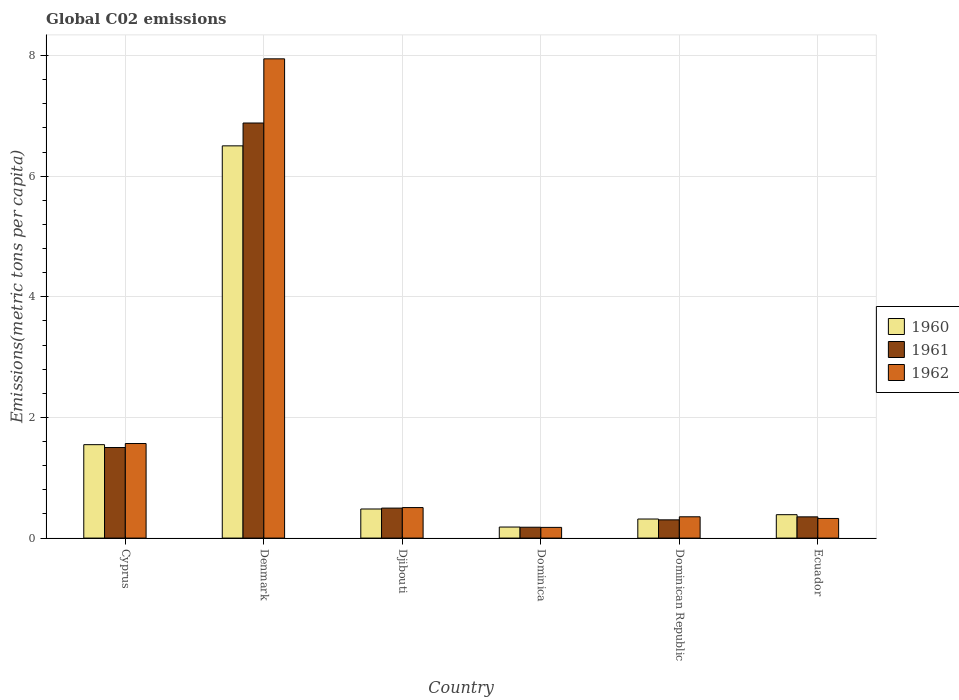How many different coloured bars are there?
Provide a succinct answer. 3. Are the number of bars on each tick of the X-axis equal?
Ensure brevity in your answer.  Yes. How many bars are there on the 5th tick from the right?
Your answer should be compact. 3. What is the label of the 4th group of bars from the left?
Offer a terse response. Dominica. In how many cases, is the number of bars for a given country not equal to the number of legend labels?
Your answer should be compact. 0. What is the amount of CO2 emitted in in 1960 in Denmark?
Your answer should be very brief. 6.5. Across all countries, what is the maximum amount of CO2 emitted in in 1961?
Ensure brevity in your answer.  6.88. Across all countries, what is the minimum amount of CO2 emitted in in 1960?
Ensure brevity in your answer.  0.18. In which country was the amount of CO2 emitted in in 1961 minimum?
Provide a short and direct response. Dominica. What is the total amount of CO2 emitted in in 1961 in the graph?
Offer a very short reply. 9.71. What is the difference between the amount of CO2 emitted in in 1960 in Dominica and that in Ecuador?
Your answer should be compact. -0.2. What is the difference between the amount of CO2 emitted in in 1960 in Djibouti and the amount of CO2 emitted in in 1961 in Denmark?
Your answer should be compact. -6.4. What is the average amount of CO2 emitted in in 1962 per country?
Offer a terse response. 1.81. What is the difference between the amount of CO2 emitted in of/in 1961 and amount of CO2 emitted in of/in 1962 in Djibouti?
Give a very brief answer. -0.01. What is the ratio of the amount of CO2 emitted in in 1961 in Dominica to that in Dominican Republic?
Offer a terse response. 0.6. Is the difference between the amount of CO2 emitted in in 1961 in Cyprus and Dominica greater than the difference between the amount of CO2 emitted in in 1962 in Cyprus and Dominica?
Ensure brevity in your answer.  No. What is the difference between the highest and the second highest amount of CO2 emitted in in 1961?
Provide a succinct answer. -1. What is the difference between the highest and the lowest amount of CO2 emitted in in 1960?
Ensure brevity in your answer.  6.32. In how many countries, is the amount of CO2 emitted in in 1962 greater than the average amount of CO2 emitted in in 1962 taken over all countries?
Offer a very short reply. 1. What does the 2nd bar from the left in Dominican Republic represents?
Offer a very short reply. 1961. What does the 2nd bar from the right in Dominica represents?
Provide a succinct answer. 1961. Is it the case that in every country, the sum of the amount of CO2 emitted in in 1961 and amount of CO2 emitted in in 1962 is greater than the amount of CO2 emitted in in 1960?
Keep it short and to the point. Yes. How many countries are there in the graph?
Ensure brevity in your answer.  6. What is the difference between two consecutive major ticks on the Y-axis?
Your response must be concise. 2. Does the graph contain any zero values?
Give a very brief answer. No. Does the graph contain grids?
Keep it short and to the point. Yes. How are the legend labels stacked?
Make the answer very short. Vertical. What is the title of the graph?
Make the answer very short. Global C02 emissions. What is the label or title of the Y-axis?
Keep it short and to the point. Emissions(metric tons per capita). What is the Emissions(metric tons per capita) of 1960 in Cyprus?
Provide a short and direct response. 1.55. What is the Emissions(metric tons per capita) in 1961 in Cyprus?
Offer a very short reply. 1.5. What is the Emissions(metric tons per capita) of 1962 in Cyprus?
Your answer should be very brief. 1.57. What is the Emissions(metric tons per capita) in 1960 in Denmark?
Your answer should be very brief. 6.5. What is the Emissions(metric tons per capita) of 1961 in Denmark?
Your answer should be very brief. 6.88. What is the Emissions(metric tons per capita) in 1962 in Denmark?
Offer a very short reply. 7.95. What is the Emissions(metric tons per capita) in 1960 in Djibouti?
Offer a very short reply. 0.48. What is the Emissions(metric tons per capita) in 1961 in Djibouti?
Provide a short and direct response. 0.5. What is the Emissions(metric tons per capita) of 1962 in Djibouti?
Give a very brief answer. 0.51. What is the Emissions(metric tons per capita) in 1960 in Dominica?
Provide a succinct answer. 0.18. What is the Emissions(metric tons per capita) of 1961 in Dominica?
Offer a terse response. 0.18. What is the Emissions(metric tons per capita) in 1962 in Dominica?
Offer a very short reply. 0.18. What is the Emissions(metric tons per capita) of 1960 in Dominican Republic?
Your answer should be compact. 0.32. What is the Emissions(metric tons per capita) of 1961 in Dominican Republic?
Make the answer very short. 0.3. What is the Emissions(metric tons per capita) in 1962 in Dominican Republic?
Keep it short and to the point. 0.35. What is the Emissions(metric tons per capita) of 1960 in Ecuador?
Ensure brevity in your answer.  0.39. What is the Emissions(metric tons per capita) of 1961 in Ecuador?
Your answer should be compact. 0.35. What is the Emissions(metric tons per capita) of 1962 in Ecuador?
Your answer should be compact. 0.33. Across all countries, what is the maximum Emissions(metric tons per capita) in 1960?
Provide a succinct answer. 6.5. Across all countries, what is the maximum Emissions(metric tons per capita) of 1961?
Provide a succinct answer. 6.88. Across all countries, what is the maximum Emissions(metric tons per capita) in 1962?
Your response must be concise. 7.95. Across all countries, what is the minimum Emissions(metric tons per capita) of 1960?
Make the answer very short. 0.18. Across all countries, what is the minimum Emissions(metric tons per capita) in 1961?
Give a very brief answer. 0.18. Across all countries, what is the minimum Emissions(metric tons per capita) of 1962?
Offer a very short reply. 0.18. What is the total Emissions(metric tons per capita) in 1960 in the graph?
Your response must be concise. 9.42. What is the total Emissions(metric tons per capita) of 1961 in the graph?
Your response must be concise. 9.71. What is the total Emissions(metric tons per capita) of 1962 in the graph?
Your answer should be compact. 10.87. What is the difference between the Emissions(metric tons per capita) of 1960 in Cyprus and that in Denmark?
Keep it short and to the point. -4.95. What is the difference between the Emissions(metric tons per capita) of 1961 in Cyprus and that in Denmark?
Your response must be concise. -5.38. What is the difference between the Emissions(metric tons per capita) of 1962 in Cyprus and that in Denmark?
Provide a short and direct response. -6.38. What is the difference between the Emissions(metric tons per capita) in 1960 in Cyprus and that in Djibouti?
Your answer should be very brief. 1.07. What is the difference between the Emissions(metric tons per capita) in 1961 in Cyprus and that in Djibouti?
Your response must be concise. 1. What is the difference between the Emissions(metric tons per capita) of 1962 in Cyprus and that in Djibouti?
Make the answer very short. 1.06. What is the difference between the Emissions(metric tons per capita) in 1960 in Cyprus and that in Dominica?
Keep it short and to the point. 1.37. What is the difference between the Emissions(metric tons per capita) in 1961 in Cyprus and that in Dominica?
Provide a succinct answer. 1.32. What is the difference between the Emissions(metric tons per capita) in 1962 in Cyprus and that in Dominica?
Your answer should be compact. 1.39. What is the difference between the Emissions(metric tons per capita) in 1960 in Cyprus and that in Dominican Republic?
Your answer should be compact. 1.23. What is the difference between the Emissions(metric tons per capita) in 1961 in Cyprus and that in Dominican Republic?
Offer a terse response. 1.2. What is the difference between the Emissions(metric tons per capita) of 1962 in Cyprus and that in Dominican Republic?
Ensure brevity in your answer.  1.21. What is the difference between the Emissions(metric tons per capita) in 1960 in Cyprus and that in Ecuador?
Ensure brevity in your answer.  1.16. What is the difference between the Emissions(metric tons per capita) in 1961 in Cyprus and that in Ecuador?
Your answer should be compact. 1.15. What is the difference between the Emissions(metric tons per capita) of 1962 in Cyprus and that in Ecuador?
Your answer should be compact. 1.24. What is the difference between the Emissions(metric tons per capita) in 1960 in Denmark and that in Djibouti?
Give a very brief answer. 6.02. What is the difference between the Emissions(metric tons per capita) of 1961 in Denmark and that in Djibouti?
Your response must be concise. 6.38. What is the difference between the Emissions(metric tons per capita) in 1962 in Denmark and that in Djibouti?
Your response must be concise. 7.44. What is the difference between the Emissions(metric tons per capita) in 1960 in Denmark and that in Dominica?
Provide a succinct answer. 6.32. What is the difference between the Emissions(metric tons per capita) in 1961 in Denmark and that in Dominica?
Keep it short and to the point. 6.7. What is the difference between the Emissions(metric tons per capita) in 1962 in Denmark and that in Dominica?
Your answer should be compact. 7.77. What is the difference between the Emissions(metric tons per capita) in 1960 in Denmark and that in Dominican Republic?
Keep it short and to the point. 6.19. What is the difference between the Emissions(metric tons per capita) in 1961 in Denmark and that in Dominican Republic?
Your answer should be very brief. 6.58. What is the difference between the Emissions(metric tons per capita) of 1962 in Denmark and that in Dominican Republic?
Keep it short and to the point. 7.59. What is the difference between the Emissions(metric tons per capita) in 1960 in Denmark and that in Ecuador?
Your answer should be very brief. 6.11. What is the difference between the Emissions(metric tons per capita) in 1961 in Denmark and that in Ecuador?
Ensure brevity in your answer.  6.53. What is the difference between the Emissions(metric tons per capita) of 1962 in Denmark and that in Ecuador?
Your answer should be very brief. 7.62. What is the difference between the Emissions(metric tons per capita) of 1960 in Djibouti and that in Dominica?
Your answer should be very brief. 0.3. What is the difference between the Emissions(metric tons per capita) of 1961 in Djibouti and that in Dominica?
Provide a short and direct response. 0.32. What is the difference between the Emissions(metric tons per capita) in 1962 in Djibouti and that in Dominica?
Offer a terse response. 0.33. What is the difference between the Emissions(metric tons per capita) of 1960 in Djibouti and that in Dominican Republic?
Ensure brevity in your answer.  0.17. What is the difference between the Emissions(metric tons per capita) of 1961 in Djibouti and that in Dominican Republic?
Provide a succinct answer. 0.19. What is the difference between the Emissions(metric tons per capita) of 1962 in Djibouti and that in Dominican Republic?
Your answer should be very brief. 0.15. What is the difference between the Emissions(metric tons per capita) in 1960 in Djibouti and that in Ecuador?
Give a very brief answer. 0.09. What is the difference between the Emissions(metric tons per capita) of 1961 in Djibouti and that in Ecuador?
Provide a short and direct response. 0.15. What is the difference between the Emissions(metric tons per capita) of 1962 in Djibouti and that in Ecuador?
Make the answer very short. 0.18. What is the difference between the Emissions(metric tons per capita) in 1960 in Dominica and that in Dominican Republic?
Offer a very short reply. -0.13. What is the difference between the Emissions(metric tons per capita) in 1961 in Dominica and that in Dominican Republic?
Ensure brevity in your answer.  -0.12. What is the difference between the Emissions(metric tons per capita) in 1962 in Dominica and that in Dominican Republic?
Give a very brief answer. -0.18. What is the difference between the Emissions(metric tons per capita) in 1960 in Dominica and that in Ecuador?
Make the answer very short. -0.2. What is the difference between the Emissions(metric tons per capita) of 1961 in Dominica and that in Ecuador?
Keep it short and to the point. -0.17. What is the difference between the Emissions(metric tons per capita) of 1962 in Dominica and that in Ecuador?
Give a very brief answer. -0.15. What is the difference between the Emissions(metric tons per capita) of 1960 in Dominican Republic and that in Ecuador?
Keep it short and to the point. -0.07. What is the difference between the Emissions(metric tons per capita) of 1961 in Dominican Republic and that in Ecuador?
Your answer should be compact. -0.05. What is the difference between the Emissions(metric tons per capita) in 1962 in Dominican Republic and that in Ecuador?
Your answer should be compact. 0.03. What is the difference between the Emissions(metric tons per capita) in 1960 in Cyprus and the Emissions(metric tons per capita) in 1961 in Denmark?
Give a very brief answer. -5.33. What is the difference between the Emissions(metric tons per capita) of 1960 in Cyprus and the Emissions(metric tons per capita) of 1962 in Denmark?
Your response must be concise. -6.4. What is the difference between the Emissions(metric tons per capita) of 1961 in Cyprus and the Emissions(metric tons per capita) of 1962 in Denmark?
Provide a succinct answer. -6.44. What is the difference between the Emissions(metric tons per capita) of 1960 in Cyprus and the Emissions(metric tons per capita) of 1961 in Djibouti?
Offer a very short reply. 1.05. What is the difference between the Emissions(metric tons per capita) of 1960 in Cyprus and the Emissions(metric tons per capita) of 1962 in Djibouti?
Provide a short and direct response. 1.04. What is the difference between the Emissions(metric tons per capita) in 1960 in Cyprus and the Emissions(metric tons per capita) in 1961 in Dominica?
Ensure brevity in your answer.  1.37. What is the difference between the Emissions(metric tons per capita) of 1960 in Cyprus and the Emissions(metric tons per capita) of 1962 in Dominica?
Make the answer very short. 1.37. What is the difference between the Emissions(metric tons per capita) in 1961 in Cyprus and the Emissions(metric tons per capita) in 1962 in Dominica?
Ensure brevity in your answer.  1.32. What is the difference between the Emissions(metric tons per capita) in 1960 in Cyprus and the Emissions(metric tons per capita) in 1961 in Dominican Republic?
Keep it short and to the point. 1.25. What is the difference between the Emissions(metric tons per capita) in 1960 in Cyprus and the Emissions(metric tons per capita) in 1962 in Dominican Republic?
Give a very brief answer. 1.2. What is the difference between the Emissions(metric tons per capita) of 1961 in Cyprus and the Emissions(metric tons per capita) of 1962 in Dominican Republic?
Keep it short and to the point. 1.15. What is the difference between the Emissions(metric tons per capita) of 1960 in Cyprus and the Emissions(metric tons per capita) of 1961 in Ecuador?
Your answer should be very brief. 1.2. What is the difference between the Emissions(metric tons per capita) of 1960 in Cyprus and the Emissions(metric tons per capita) of 1962 in Ecuador?
Keep it short and to the point. 1.22. What is the difference between the Emissions(metric tons per capita) of 1961 in Cyprus and the Emissions(metric tons per capita) of 1962 in Ecuador?
Your response must be concise. 1.18. What is the difference between the Emissions(metric tons per capita) in 1960 in Denmark and the Emissions(metric tons per capita) in 1961 in Djibouti?
Your answer should be very brief. 6.01. What is the difference between the Emissions(metric tons per capita) in 1960 in Denmark and the Emissions(metric tons per capita) in 1962 in Djibouti?
Provide a succinct answer. 6. What is the difference between the Emissions(metric tons per capita) in 1961 in Denmark and the Emissions(metric tons per capita) in 1962 in Djibouti?
Offer a very short reply. 6.38. What is the difference between the Emissions(metric tons per capita) in 1960 in Denmark and the Emissions(metric tons per capita) in 1961 in Dominica?
Provide a succinct answer. 6.32. What is the difference between the Emissions(metric tons per capita) of 1960 in Denmark and the Emissions(metric tons per capita) of 1962 in Dominica?
Provide a short and direct response. 6.33. What is the difference between the Emissions(metric tons per capita) of 1961 in Denmark and the Emissions(metric tons per capita) of 1962 in Dominica?
Keep it short and to the point. 6.7. What is the difference between the Emissions(metric tons per capita) of 1960 in Denmark and the Emissions(metric tons per capita) of 1961 in Dominican Republic?
Your answer should be compact. 6.2. What is the difference between the Emissions(metric tons per capita) of 1960 in Denmark and the Emissions(metric tons per capita) of 1962 in Dominican Republic?
Give a very brief answer. 6.15. What is the difference between the Emissions(metric tons per capita) of 1961 in Denmark and the Emissions(metric tons per capita) of 1962 in Dominican Republic?
Your answer should be very brief. 6.53. What is the difference between the Emissions(metric tons per capita) in 1960 in Denmark and the Emissions(metric tons per capita) in 1961 in Ecuador?
Keep it short and to the point. 6.15. What is the difference between the Emissions(metric tons per capita) of 1960 in Denmark and the Emissions(metric tons per capita) of 1962 in Ecuador?
Offer a terse response. 6.18. What is the difference between the Emissions(metric tons per capita) of 1961 in Denmark and the Emissions(metric tons per capita) of 1962 in Ecuador?
Provide a short and direct response. 6.56. What is the difference between the Emissions(metric tons per capita) in 1960 in Djibouti and the Emissions(metric tons per capita) in 1961 in Dominica?
Give a very brief answer. 0.3. What is the difference between the Emissions(metric tons per capita) of 1960 in Djibouti and the Emissions(metric tons per capita) of 1962 in Dominica?
Give a very brief answer. 0.3. What is the difference between the Emissions(metric tons per capita) in 1961 in Djibouti and the Emissions(metric tons per capita) in 1962 in Dominica?
Keep it short and to the point. 0.32. What is the difference between the Emissions(metric tons per capita) of 1960 in Djibouti and the Emissions(metric tons per capita) of 1961 in Dominican Republic?
Provide a succinct answer. 0.18. What is the difference between the Emissions(metric tons per capita) in 1960 in Djibouti and the Emissions(metric tons per capita) in 1962 in Dominican Republic?
Make the answer very short. 0.13. What is the difference between the Emissions(metric tons per capita) in 1961 in Djibouti and the Emissions(metric tons per capita) in 1962 in Dominican Republic?
Keep it short and to the point. 0.14. What is the difference between the Emissions(metric tons per capita) in 1960 in Djibouti and the Emissions(metric tons per capita) in 1961 in Ecuador?
Your answer should be very brief. 0.13. What is the difference between the Emissions(metric tons per capita) in 1960 in Djibouti and the Emissions(metric tons per capita) in 1962 in Ecuador?
Provide a succinct answer. 0.16. What is the difference between the Emissions(metric tons per capita) of 1961 in Djibouti and the Emissions(metric tons per capita) of 1962 in Ecuador?
Your response must be concise. 0.17. What is the difference between the Emissions(metric tons per capita) of 1960 in Dominica and the Emissions(metric tons per capita) of 1961 in Dominican Republic?
Your answer should be very brief. -0.12. What is the difference between the Emissions(metric tons per capita) in 1960 in Dominica and the Emissions(metric tons per capita) in 1962 in Dominican Republic?
Offer a terse response. -0.17. What is the difference between the Emissions(metric tons per capita) in 1961 in Dominica and the Emissions(metric tons per capita) in 1962 in Dominican Republic?
Your response must be concise. -0.17. What is the difference between the Emissions(metric tons per capita) in 1960 in Dominica and the Emissions(metric tons per capita) in 1961 in Ecuador?
Ensure brevity in your answer.  -0.17. What is the difference between the Emissions(metric tons per capita) of 1960 in Dominica and the Emissions(metric tons per capita) of 1962 in Ecuador?
Ensure brevity in your answer.  -0.14. What is the difference between the Emissions(metric tons per capita) in 1961 in Dominica and the Emissions(metric tons per capita) in 1962 in Ecuador?
Offer a very short reply. -0.15. What is the difference between the Emissions(metric tons per capita) in 1960 in Dominican Republic and the Emissions(metric tons per capita) in 1961 in Ecuador?
Give a very brief answer. -0.04. What is the difference between the Emissions(metric tons per capita) in 1960 in Dominican Republic and the Emissions(metric tons per capita) in 1962 in Ecuador?
Offer a terse response. -0.01. What is the difference between the Emissions(metric tons per capita) of 1961 in Dominican Republic and the Emissions(metric tons per capita) of 1962 in Ecuador?
Offer a very short reply. -0.02. What is the average Emissions(metric tons per capita) of 1960 per country?
Offer a very short reply. 1.57. What is the average Emissions(metric tons per capita) in 1961 per country?
Keep it short and to the point. 1.62. What is the average Emissions(metric tons per capita) of 1962 per country?
Provide a succinct answer. 1.81. What is the difference between the Emissions(metric tons per capita) in 1960 and Emissions(metric tons per capita) in 1961 in Cyprus?
Give a very brief answer. 0.05. What is the difference between the Emissions(metric tons per capita) in 1960 and Emissions(metric tons per capita) in 1962 in Cyprus?
Offer a terse response. -0.02. What is the difference between the Emissions(metric tons per capita) of 1961 and Emissions(metric tons per capita) of 1962 in Cyprus?
Your response must be concise. -0.07. What is the difference between the Emissions(metric tons per capita) in 1960 and Emissions(metric tons per capita) in 1961 in Denmark?
Offer a very short reply. -0.38. What is the difference between the Emissions(metric tons per capita) of 1960 and Emissions(metric tons per capita) of 1962 in Denmark?
Provide a succinct answer. -1.44. What is the difference between the Emissions(metric tons per capita) of 1961 and Emissions(metric tons per capita) of 1962 in Denmark?
Your answer should be compact. -1.06. What is the difference between the Emissions(metric tons per capita) of 1960 and Emissions(metric tons per capita) of 1961 in Djibouti?
Make the answer very short. -0.01. What is the difference between the Emissions(metric tons per capita) of 1960 and Emissions(metric tons per capita) of 1962 in Djibouti?
Provide a short and direct response. -0.02. What is the difference between the Emissions(metric tons per capita) in 1961 and Emissions(metric tons per capita) in 1962 in Djibouti?
Provide a succinct answer. -0.01. What is the difference between the Emissions(metric tons per capita) in 1960 and Emissions(metric tons per capita) in 1961 in Dominica?
Offer a very short reply. 0. What is the difference between the Emissions(metric tons per capita) in 1960 and Emissions(metric tons per capita) in 1962 in Dominica?
Your answer should be very brief. 0.01. What is the difference between the Emissions(metric tons per capita) of 1961 and Emissions(metric tons per capita) of 1962 in Dominica?
Provide a succinct answer. 0. What is the difference between the Emissions(metric tons per capita) of 1960 and Emissions(metric tons per capita) of 1961 in Dominican Republic?
Provide a succinct answer. 0.01. What is the difference between the Emissions(metric tons per capita) of 1960 and Emissions(metric tons per capita) of 1962 in Dominican Republic?
Your response must be concise. -0.04. What is the difference between the Emissions(metric tons per capita) of 1961 and Emissions(metric tons per capita) of 1962 in Dominican Republic?
Provide a succinct answer. -0.05. What is the difference between the Emissions(metric tons per capita) in 1960 and Emissions(metric tons per capita) in 1961 in Ecuador?
Provide a short and direct response. 0.04. What is the difference between the Emissions(metric tons per capita) of 1960 and Emissions(metric tons per capita) of 1962 in Ecuador?
Make the answer very short. 0.06. What is the difference between the Emissions(metric tons per capita) of 1961 and Emissions(metric tons per capita) of 1962 in Ecuador?
Give a very brief answer. 0.03. What is the ratio of the Emissions(metric tons per capita) in 1960 in Cyprus to that in Denmark?
Offer a very short reply. 0.24. What is the ratio of the Emissions(metric tons per capita) in 1961 in Cyprus to that in Denmark?
Your answer should be very brief. 0.22. What is the ratio of the Emissions(metric tons per capita) in 1962 in Cyprus to that in Denmark?
Provide a short and direct response. 0.2. What is the ratio of the Emissions(metric tons per capita) of 1960 in Cyprus to that in Djibouti?
Ensure brevity in your answer.  3.21. What is the ratio of the Emissions(metric tons per capita) in 1961 in Cyprus to that in Djibouti?
Your answer should be compact. 3.02. What is the ratio of the Emissions(metric tons per capita) in 1962 in Cyprus to that in Djibouti?
Your answer should be compact. 3.1. What is the ratio of the Emissions(metric tons per capita) of 1960 in Cyprus to that in Dominica?
Your answer should be very brief. 8.45. What is the ratio of the Emissions(metric tons per capita) in 1961 in Cyprus to that in Dominica?
Ensure brevity in your answer.  8.33. What is the ratio of the Emissions(metric tons per capita) of 1962 in Cyprus to that in Dominica?
Provide a short and direct response. 8.83. What is the ratio of the Emissions(metric tons per capita) in 1960 in Cyprus to that in Dominican Republic?
Provide a short and direct response. 4.9. What is the ratio of the Emissions(metric tons per capita) in 1961 in Cyprus to that in Dominican Republic?
Your response must be concise. 4.96. What is the ratio of the Emissions(metric tons per capita) in 1962 in Cyprus to that in Dominican Republic?
Give a very brief answer. 4.44. What is the ratio of the Emissions(metric tons per capita) of 1960 in Cyprus to that in Ecuador?
Make the answer very short. 3.99. What is the ratio of the Emissions(metric tons per capita) in 1961 in Cyprus to that in Ecuador?
Provide a short and direct response. 4.26. What is the ratio of the Emissions(metric tons per capita) of 1962 in Cyprus to that in Ecuador?
Your response must be concise. 4.82. What is the ratio of the Emissions(metric tons per capita) in 1960 in Denmark to that in Djibouti?
Give a very brief answer. 13.48. What is the ratio of the Emissions(metric tons per capita) of 1961 in Denmark to that in Djibouti?
Your answer should be very brief. 13.84. What is the ratio of the Emissions(metric tons per capita) of 1962 in Denmark to that in Djibouti?
Offer a very short reply. 15.7. What is the ratio of the Emissions(metric tons per capita) of 1960 in Denmark to that in Dominica?
Make the answer very short. 35.48. What is the ratio of the Emissions(metric tons per capita) of 1961 in Denmark to that in Dominica?
Ensure brevity in your answer.  38.18. What is the ratio of the Emissions(metric tons per capita) of 1962 in Denmark to that in Dominica?
Make the answer very short. 44.77. What is the ratio of the Emissions(metric tons per capita) in 1960 in Denmark to that in Dominican Republic?
Your answer should be compact. 20.57. What is the ratio of the Emissions(metric tons per capita) of 1961 in Denmark to that in Dominican Republic?
Your answer should be very brief. 22.75. What is the ratio of the Emissions(metric tons per capita) of 1962 in Denmark to that in Dominican Republic?
Ensure brevity in your answer.  22.51. What is the ratio of the Emissions(metric tons per capita) of 1960 in Denmark to that in Ecuador?
Provide a short and direct response. 16.76. What is the ratio of the Emissions(metric tons per capita) in 1961 in Denmark to that in Ecuador?
Make the answer very short. 19.55. What is the ratio of the Emissions(metric tons per capita) of 1962 in Denmark to that in Ecuador?
Your answer should be compact. 24.42. What is the ratio of the Emissions(metric tons per capita) of 1960 in Djibouti to that in Dominica?
Keep it short and to the point. 2.63. What is the ratio of the Emissions(metric tons per capita) of 1961 in Djibouti to that in Dominica?
Ensure brevity in your answer.  2.76. What is the ratio of the Emissions(metric tons per capita) in 1962 in Djibouti to that in Dominica?
Your answer should be compact. 2.85. What is the ratio of the Emissions(metric tons per capita) of 1960 in Djibouti to that in Dominican Republic?
Your answer should be compact. 1.53. What is the ratio of the Emissions(metric tons per capita) in 1961 in Djibouti to that in Dominican Republic?
Keep it short and to the point. 1.64. What is the ratio of the Emissions(metric tons per capita) in 1962 in Djibouti to that in Dominican Republic?
Provide a short and direct response. 1.43. What is the ratio of the Emissions(metric tons per capita) in 1960 in Djibouti to that in Ecuador?
Give a very brief answer. 1.24. What is the ratio of the Emissions(metric tons per capita) in 1961 in Djibouti to that in Ecuador?
Keep it short and to the point. 1.41. What is the ratio of the Emissions(metric tons per capita) in 1962 in Djibouti to that in Ecuador?
Offer a terse response. 1.56. What is the ratio of the Emissions(metric tons per capita) of 1960 in Dominica to that in Dominican Republic?
Give a very brief answer. 0.58. What is the ratio of the Emissions(metric tons per capita) of 1961 in Dominica to that in Dominican Republic?
Ensure brevity in your answer.  0.6. What is the ratio of the Emissions(metric tons per capita) in 1962 in Dominica to that in Dominican Republic?
Provide a short and direct response. 0.5. What is the ratio of the Emissions(metric tons per capita) of 1960 in Dominica to that in Ecuador?
Your response must be concise. 0.47. What is the ratio of the Emissions(metric tons per capita) of 1961 in Dominica to that in Ecuador?
Offer a terse response. 0.51. What is the ratio of the Emissions(metric tons per capita) of 1962 in Dominica to that in Ecuador?
Keep it short and to the point. 0.55. What is the ratio of the Emissions(metric tons per capita) in 1960 in Dominican Republic to that in Ecuador?
Your answer should be compact. 0.81. What is the ratio of the Emissions(metric tons per capita) in 1961 in Dominican Republic to that in Ecuador?
Give a very brief answer. 0.86. What is the ratio of the Emissions(metric tons per capita) in 1962 in Dominican Republic to that in Ecuador?
Give a very brief answer. 1.09. What is the difference between the highest and the second highest Emissions(metric tons per capita) of 1960?
Your answer should be compact. 4.95. What is the difference between the highest and the second highest Emissions(metric tons per capita) in 1961?
Offer a terse response. 5.38. What is the difference between the highest and the second highest Emissions(metric tons per capita) in 1962?
Make the answer very short. 6.38. What is the difference between the highest and the lowest Emissions(metric tons per capita) of 1960?
Give a very brief answer. 6.32. What is the difference between the highest and the lowest Emissions(metric tons per capita) of 1961?
Keep it short and to the point. 6.7. What is the difference between the highest and the lowest Emissions(metric tons per capita) in 1962?
Offer a terse response. 7.77. 